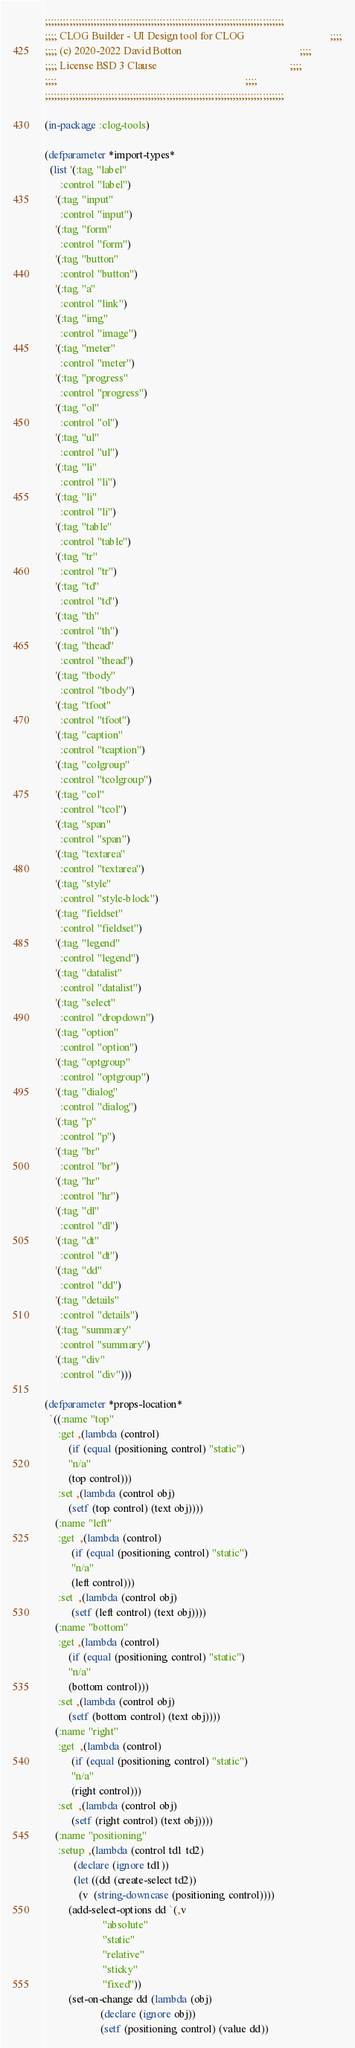<code> <loc_0><loc_0><loc_500><loc_500><_Lisp_>;;;;;;;;;;;;;;;;;;;;;;;;;;;;;;;;;;;;;;;;;;;;;;;;;;;;;;;;;;;;;;;;;;;;;;;;;;;;;;;
;;;; CLOG Builder - UI Design tool for CLOG                                ;;;;
;;;; (c) 2020-2022 David Botton                                            ;;;;
;;;; License BSD 3 Clause                                                  ;;;;
;;;;                                                                       ;;;;
;;;;;;;;;;;;;;;;;;;;;;;;;;;;;;;;;;;;;;;;;;;;;;;;;;;;;;;;;;;;;;;;;;;;;;;;;;;;;;;

(in-package :clog-tools)

(defparameter *import-types*
  (list '(:tag "label"
	  :control "label")
	'(:tag "input"
	  :control "input")
	'(:tag "form"
	  :control "form")
	'(:tag "button"
	  :control "button")
	'(:tag "a"
	  :control "link")
	'(:tag "img"
	  :control "image")
	'(:tag "meter"
	  :control "meter")
	'(:tag "progress"
	  :control "progress")
	'(:tag "ol"
	  :control "ol")
	'(:tag "ul"
	  :control "ul")
	'(:tag "li"
	  :control "li")
	'(:tag "li"
	  :control "li")
	'(:tag "table"
	  :control "table")
	'(:tag "tr"
	  :control "tr")
	'(:tag "td"
	  :control "td")
	'(:tag "th"
	  :control "th")
	'(:tag "thead"
	  :control "thead")
	'(:tag "tbody"
	  :control "tbody")
	'(:tag "tfoot"
	  :control "tfoot")
	'(:tag "caption"
	  :control "tcaption")
	'(:tag "colgroup"
	  :control "tcolgroup")
	'(:tag "col"
	  :control "tcol")
	'(:tag "span"
	  :control "span")
	'(:tag "textarea"
	  :control "textarea")
	'(:tag "style"
	  :control "style-block")
	'(:tag "fieldset"
	  :control "fieldset")
	'(:tag "legend"
	  :control "legend")
	'(:tag "datalist"
	  :control "datalist")
	'(:tag "select"
	  :control "dropdown")
	'(:tag "option"
	  :control "option")
	'(:tag "optgroup"
	  :control "optgroup")
	'(:tag "dialog"
	  :control "dialog")
	'(:tag "p"
	  :control "p")
	'(:tag "br"
	  :control "br")
	'(:tag "hr"
	  :control "hr")
	'(:tag "dl"
	  :control "dl")
	'(:tag "dt"
	  :control "dt")
	'(:tag "dd"
	  :control "dd")
	'(:tag "details"
	  :control "details")
	'(:tag "summary"
	  :control "summary")
	'(:tag "div"
	  :control "div")))

(defparameter *props-location*
  `((:name "top"
     :get ,(lambda (control)
	     (if (equal (positioning control) "static")
		 "n/a"
		 (top control)))
     :set ,(lambda (control obj)
	     (setf (top control) (text obj))))
    (:name "left"
     :get  ,(lambda (control)
	      (if (equal (positioning control) "static")
		  "n/a"
		  (left control)))
     :set  ,(lambda (control obj)
	      (setf (left control) (text obj))))
    (:name "bottom"
     :get ,(lambda (control)
	     (if (equal (positioning control) "static")
		 "n/a"
		 (bottom control)))
     :set ,(lambda (control obj)
	     (setf (bottom control) (text obj))))
    (:name "right"
     :get  ,(lambda (control)
	      (if (equal (positioning control) "static")
		  "n/a"
		  (right control)))
     :set  ,(lambda (control obj)
	      (setf (right control) (text obj))))
    (:name "positioning"
     :setup ,(lambda (control td1 td2)
	       (declare (ignore td1))
	       (let ((dd (create-select td2))
		     (v  (string-downcase (positioning control))))
		 (add-select-options dd `(,v
					  "absolute"
					  "static"
					  "relative"
					  "sticky"
					  "fixed"))
		 (set-on-change dd (lambda (obj)
				     (declare (ignore obj))
				     (setf (positioning control) (value dd))</code> 